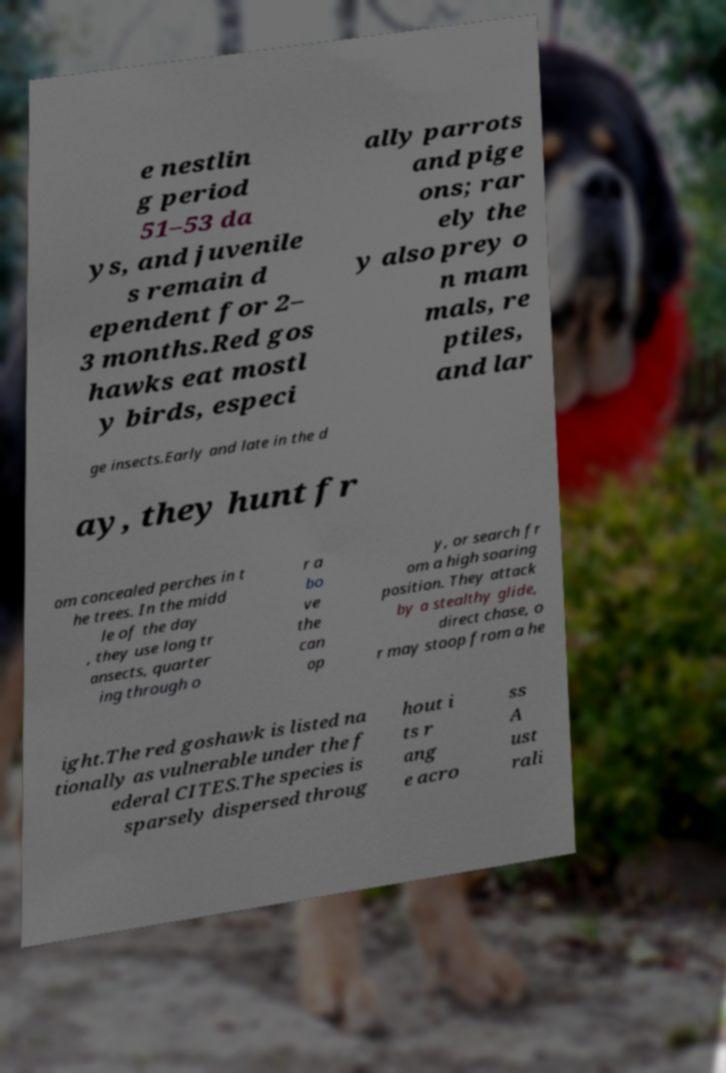For documentation purposes, I need the text within this image transcribed. Could you provide that? e nestlin g period 51–53 da ys, and juvenile s remain d ependent for 2– 3 months.Red gos hawks eat mostl y birds, especi ally parrots and pige ons; rar ely the y also prey o n mam mals, re ptiles, and lar ge insects.Early and late in the d ay, they hunt fr om concealed perches in t he trees. In the midd le of the day , they use long tr ansects, quarter ing through o r a bo ve the can op y, or search fr om a high soaring position. They attack by a stealthy glide, direct chase, o r may stoop from a he ight.The red goshawk is listed na tionally as vulnerable under the f ederal CITES.The species is sparsely dispersed throug hout i ts r ang e acro ss A ust rali 